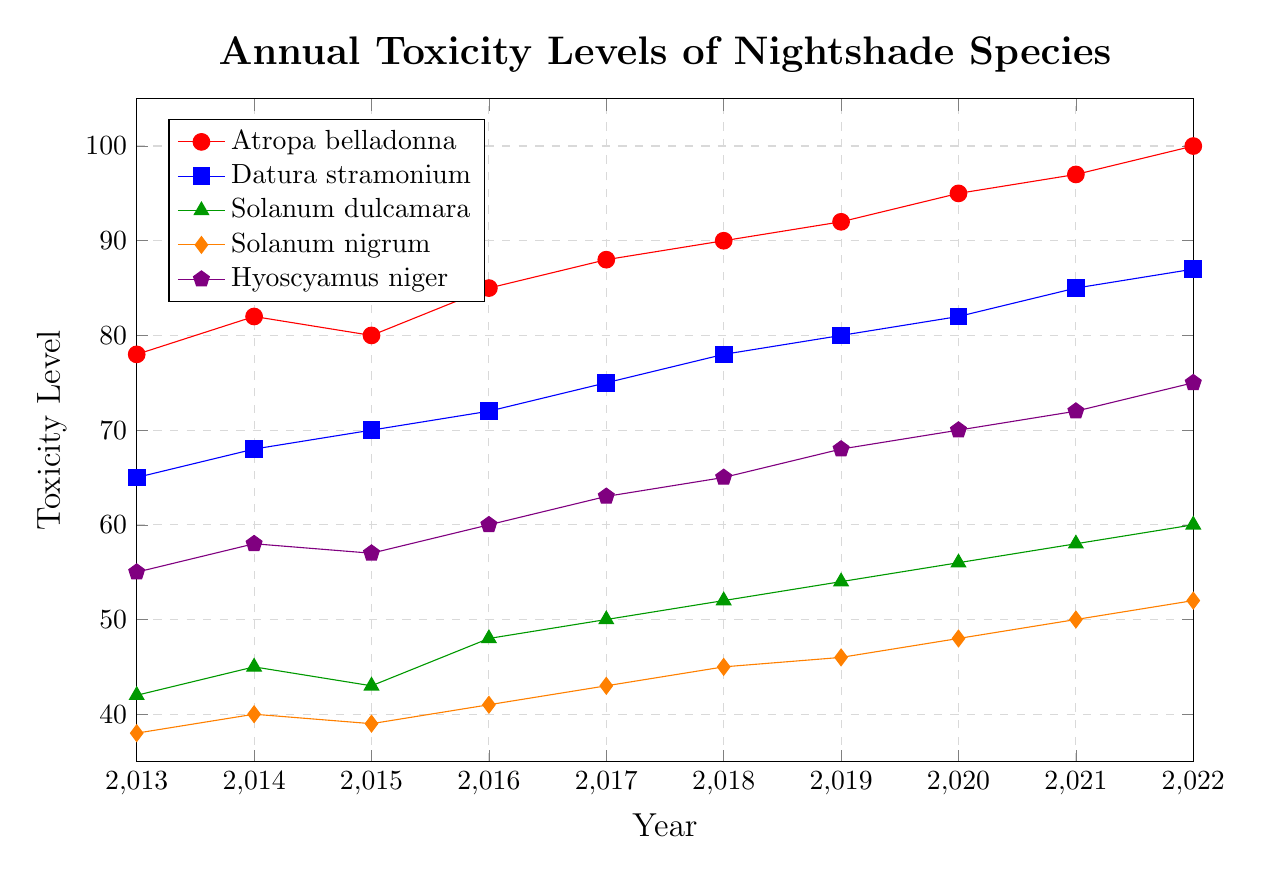Which species shows the greatest increase in toxicity levels over the 10-year period? By comparing the difference between toxicity levels in 2022 and 2013 for each species, we find Atropa belladonna increased from 78 to 100 (22 units), Datura stramonium from 65 to 87 (22 units), Solanum dulcamara from 42 to 60 (18 units), Solanum nigrum from 38 to 52 (14 units), and Hyoscyamus niger from 55 to 75 (20 units). Both Atropa belladonna and Datura stramonium show the greatest increase of 22 units each.
Answer: Atropa belladonna and Datura stramonium Which species had the smallest change in toxicity levels between 2013 and 2022? By comparing the differences in toxicity levels for the species, Solanum nigrum's change is 52 - 38 = 14 units, which is the smallest change.
Answer: Solanum nigrum Which year had the highest toxicity level for Atropa belladonna? By examining the trend in the line for Atropa belladonna, we can see that the toxicity level peaks at 100 in 2022.
Answer: 2022 Compare the toxicity levels of Datura stramonium and Solanum dulcamara in 2019. Which one is higher and by how much? In 2019, the toxicity level for Datura stramonium is 80, and for Solanum dulcamara, it is 54. The difference is 80 - 54 = 26 units, with Datura stramonium being higher.
Answer: Datura stramonium by 26 Visualize the graph and infer which species has consistently had a higher toxicity level, Atropa belladonna or Hyoscyamus niger? By observing the trend lines, Atropa belladonna consistently stays above Hyoscyamus niger across all years.
Answer: Atropa belladonna Calculate the average toxicity level for Solanum nigrum over the 10-year period. Sum the annual toxicity levels (38 + 40 + 39 + 41 + 43 + 45 + 46 + 48 + 50 + 52) = 442. Divide by the number of years (10), resulting in an average of 442 / 10 = 44.2.
Answer: 44.2 Between which years did Hyoscyamus niger see the highest increase in toxicity level? By observing the gaps year to year: 2013-2014 (55-58=3), 2014-2015 (58-57=-1), 2015-2016 (57-60=3), 2016-2017 (60-63=3), 2017-2018 (63-65=2), 2018-2019 (65-68=3), 2019-2020 (68-70=2), 2020-2021 (70-72=2), and 2021-2022 (72-75=3). The highest increases are tied at 3 units for several periods.
Answer: Multiple periods (55-58, 57-60, 60-63, 65-68, 72-75) What is the difference in toxicity levels between the highest and lowest values recorded in 2021? The highest value in 2021 is for Atropa belladonna at 97, and the lowest value is for Solanum nigrum at 50. The difference is 97 - 50 = 47.
Answer: 47 Identify the species with the least volatility in toxicity levels over the decade by examining the trend lines. By visually comparing the fluctuations in each species' trend lines, Solanum nigrum shows the least volatility with relatively minor changes year over year.
Answer: Solanum nigrum 